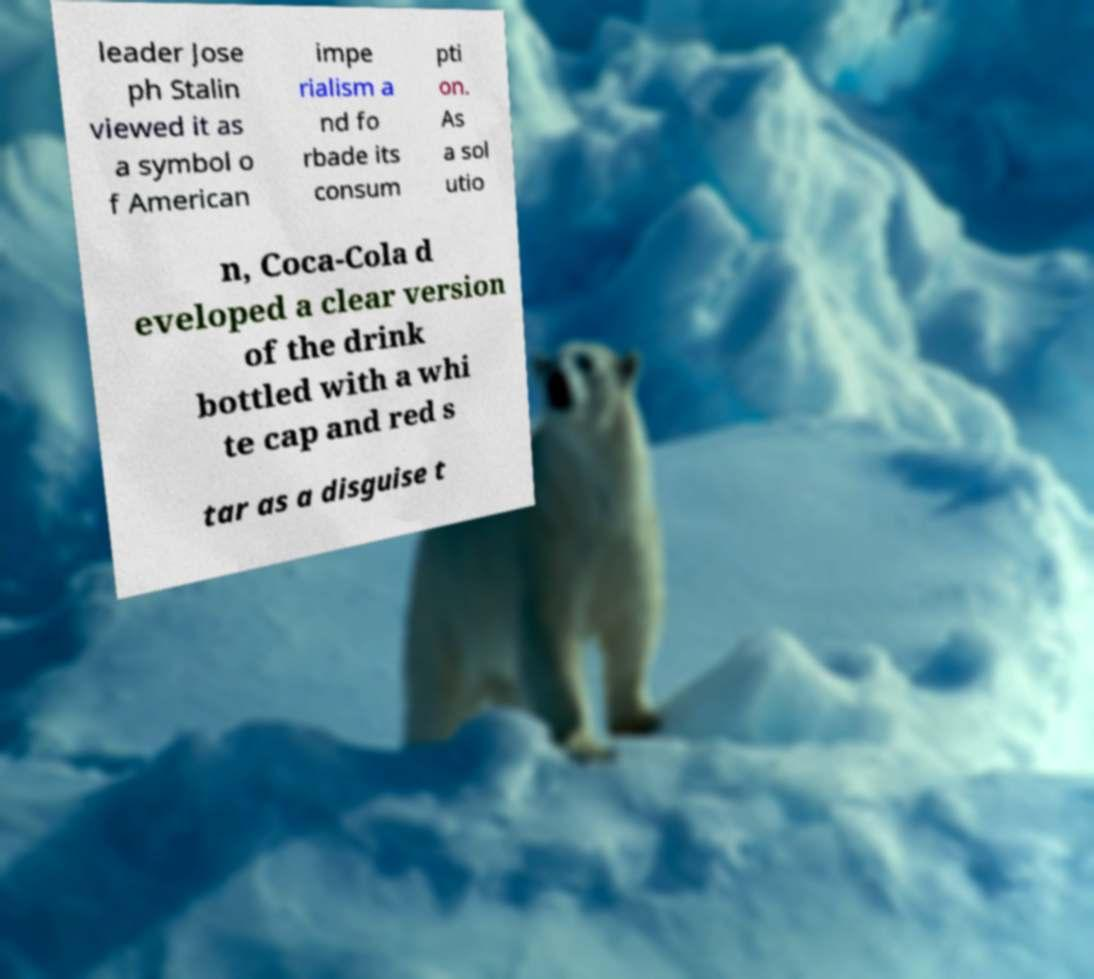Can you read and provide the text displayed in the image?This photo seems to have some interesting text. Can you extract and type it out for me? leader Jose ph Stalin viewed it as a symbol o f American impe rialism a nd fo rbade its consum pti on. As a sol utio n, Coca-Cola d eveloped a clear version of the drink bottled with a whi te cap and red s tar as a disguise t 